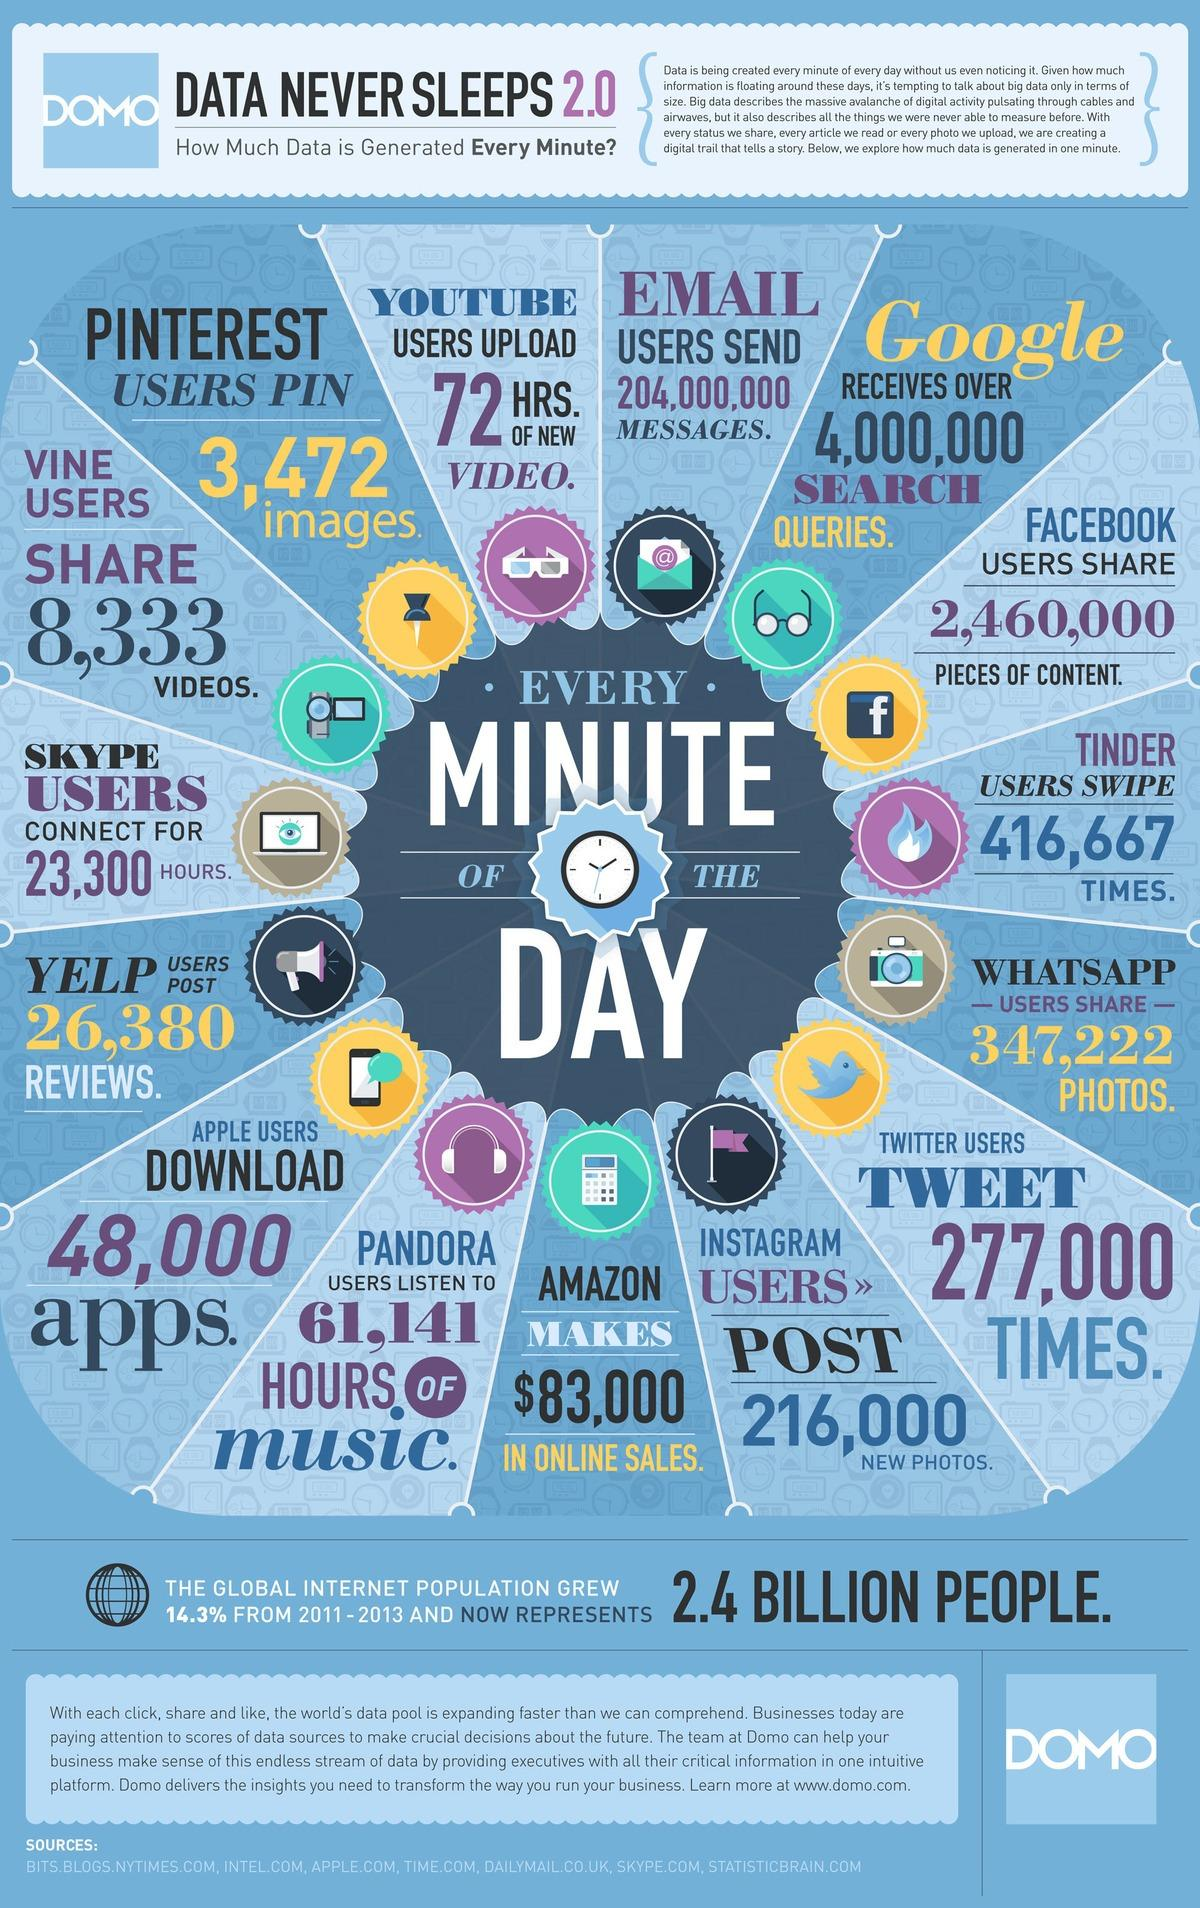Indicate a few pertinent items in this graphic. Approximately 8,333 videos are shared through Vine in a minute. In a single minute, an estimated 347,222 posts and photos are forwarded on Whatsapp. On average, approximately 277,000 tweets are posted on Twitter every minute. In Instagram, approximately 216,000 new photos are posted every minute. Google processes approximately 4 million search queries in a single minute. 